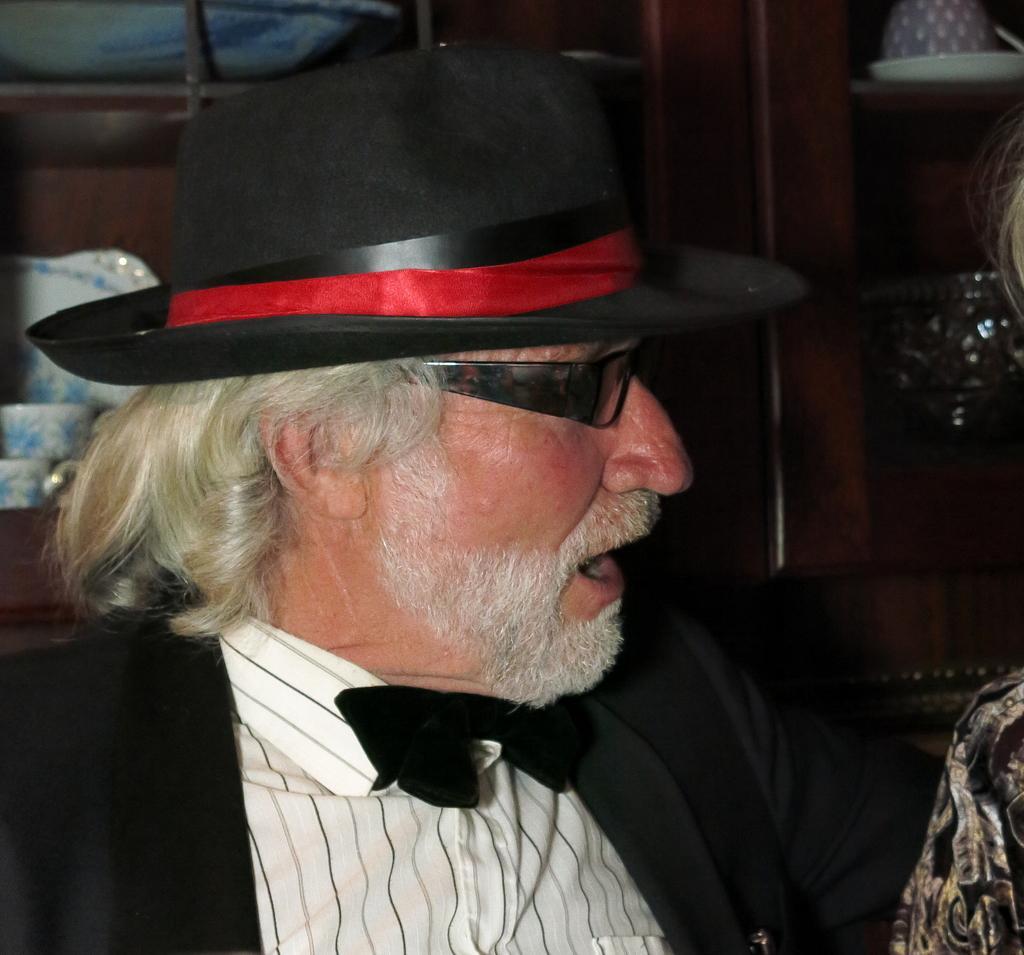How would you summarize this image in a sentence or two? In this picture I can see a man with spectacles and a hat, there is another person beside him, and in the background there are cups, plates and some other items in the shelf or a cupboard. 